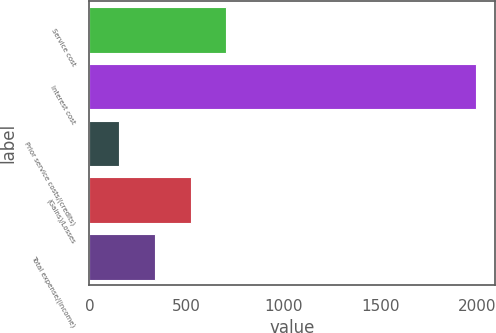Convert chart. <chart><loc_0><loc_0><loc_500><loc_500><bar_chart><fcel>Service cost<fcel>Interest cost<fcel>Prior service costs/(credits)<fcel>(Gains)/Losses<fcel>Total expense/(income)<nl><fcel>706.1<fcel>1992<fcel>155<fcel>522.4<fcel>338.7<nl></chart> 